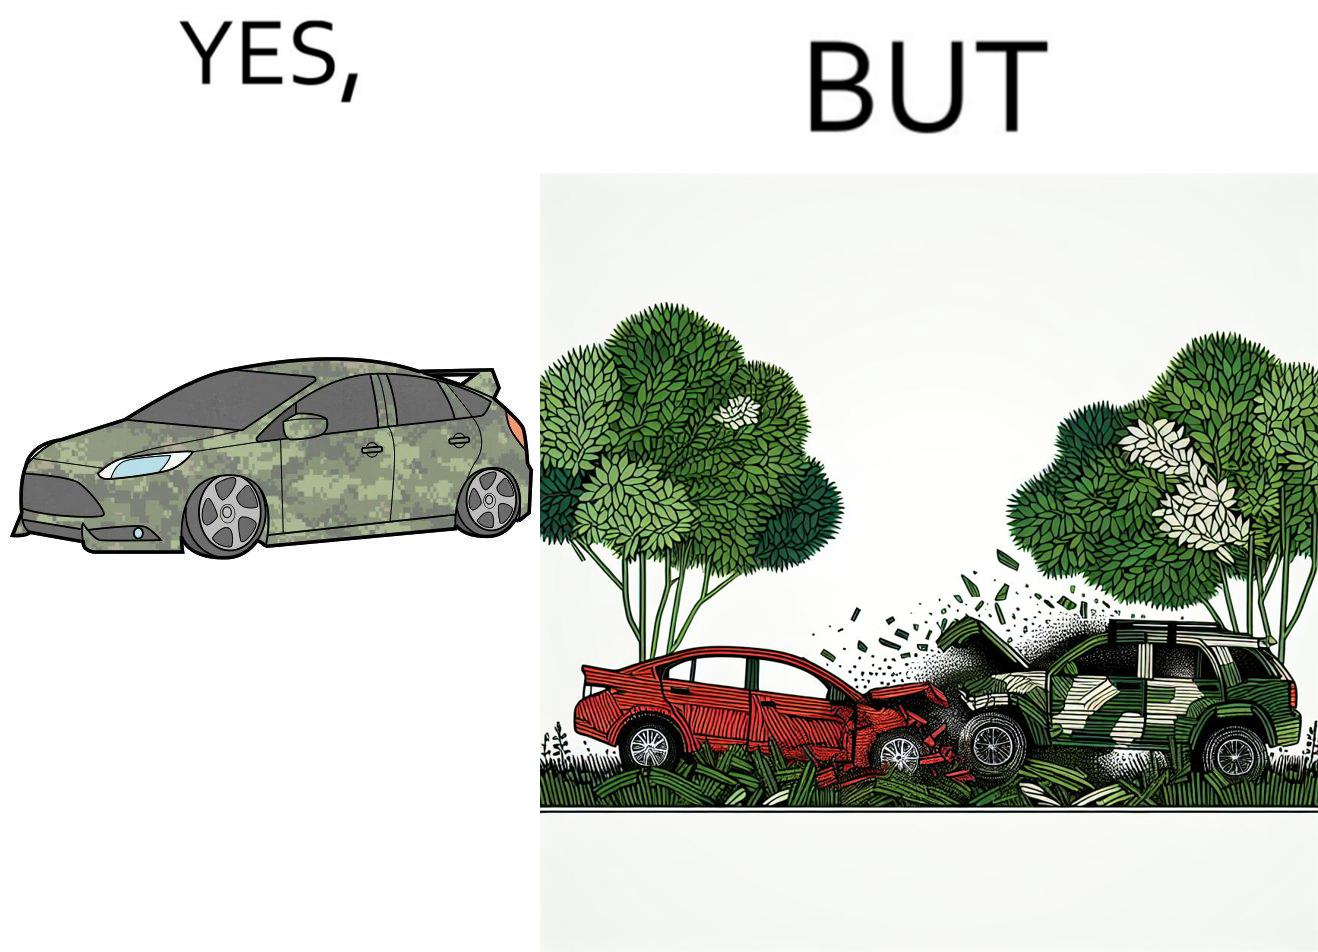Is this image satirical or non-satirical? Yes, this image is satirical. 